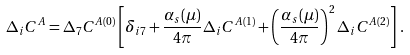<formula> <loc_0><loc_0><loc_500><loc_500>\Delta _ { i } C ^ { A } = \Delta _ { 7 } C ^ { A ( 0 ) } \left [ \delta _ { i 7 } + \frac { \alpha _ { s } ( \mu ) } { 4 \pi } \Delta _ { i } C ^ { A ( 1 ) } + \left ( \frac { \alpha _ { s } ( \mu ) } { 4 \pi } \right ) ^ { 2 } \Delta _ { i } C ^ { A ( 2 ) } \right ] \, .</formula> 